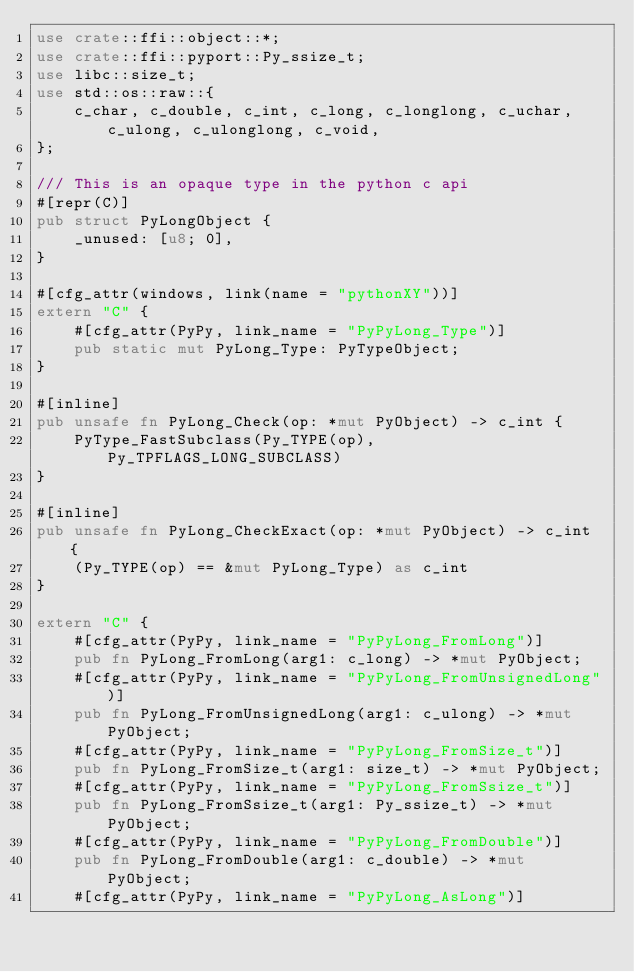<code> <loc_0><loc_0><loc_500><loc_500><_Rust_>use crate::ffi::object::*;
use crate::ffi::pyport::Py_ssize_t;
use libc::size_t;
use std::os::raw::{
    c_char, c_double, c_int, c_long, c_longlong, c_uchar, c_ulong, c_ulonglong, c_void,
};

/// This is an opaque type in the python c api
#[repr(C)]
pub struct PyLongObject {
    _unused: [u8; 0],
}

#[cfg_attr(windows, link(name = "pythonXY"))]
extern "C" {
    #[cfg_attr(PyPy, link_name = "PyPyLong_Type")]
    pub static mut PyLong_Type: PyTypeObject;
}

#[inline]
pub unsafe fn PyLong_Check(op: *mut PyObject) -> c_int {
    PyType_FastSubclass(Py_TYPE(op), Py_TPFLAGS_LONG_SUBCLASS)
}

#[inline]
pub unsafe fn PyLong_CheckExact(op: *mut PyObject) -> c_int {
    (Py_TYPE(op) == &mut PyLong_Type) as c_int
}

extern "C" {
    #[cfg_attr(PyPy, link_name = "PyPyLong_FromLong")]
    pub fn PyLong_FromLong(arg1: c_long) -> *mut PyObject;
    #[cfg_attr(PyPy, link_name = "PyPyLong_FromUnsignedLong")]
    pub fn PyLong_FromUnsignedLong(arg1: c_ulong) -> *mut PyObject;
    #[cfg_attr(PyPy, link_name = "PyPyLong_FromSize_t")]
    pub fn PyLong_FromSize_t(arg1: size_t) -> *mut PyObject;
    #[cfg_attr(PyPy, link_name = "PyPyLong_FromSsize_t")]
    pub fn PyLong_FromSsize_t(arg1: Py_ssize_t) -> *mut PyObject;
    #[cfg_attr(PyPy, link_name = "PyPyLong_FromDouble")]
    pub fn PyLong_FromDouble(arg1: c_double) -> *mut PyObject;
    #[cfg_attr(PyPy, link_name = "PyPyLong_AsLong")]</code> 